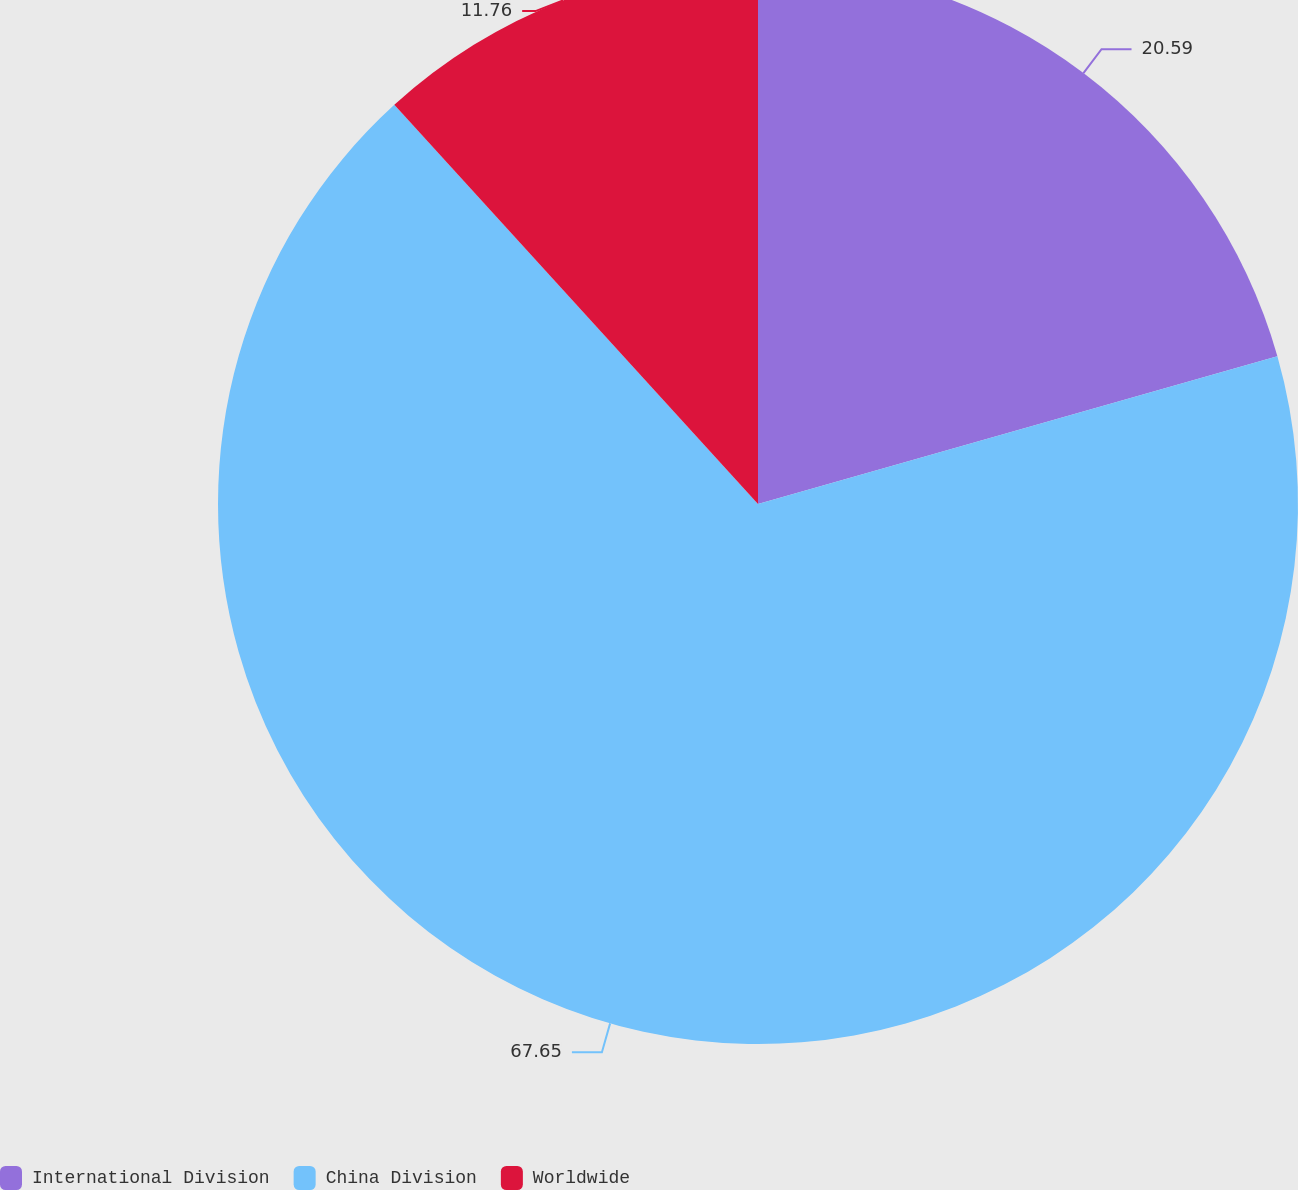<chart> <loc_0><loc_0><loc_500><loc_500><pie_chart><fcel>International Division<fcel>China Division<fcel>Worldwide<nl><fcel>20.59%<fcel>67.65%<fcel>11.76%<nl></chart> 